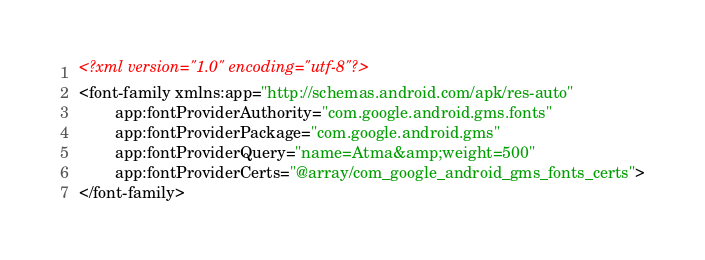<code> <loc_0><loc_0><loc_500><loc_500><_XML_><?xml version="1.0" encoding="utf-8"?>
<font-family xmlns:app="http://schemas.android.com/apk/res-auto"
        app:fontProviderAuthority="com.google.android.gms.fonts"
        app:fontProviderPackage="com.google.android.gms"
        app:fontProviderQuery="name=Atma&amp;weight=500"
        app:fontProviderCerts="@array/com_google_android_gms_fonts_certs">
</font-family>
</code> 